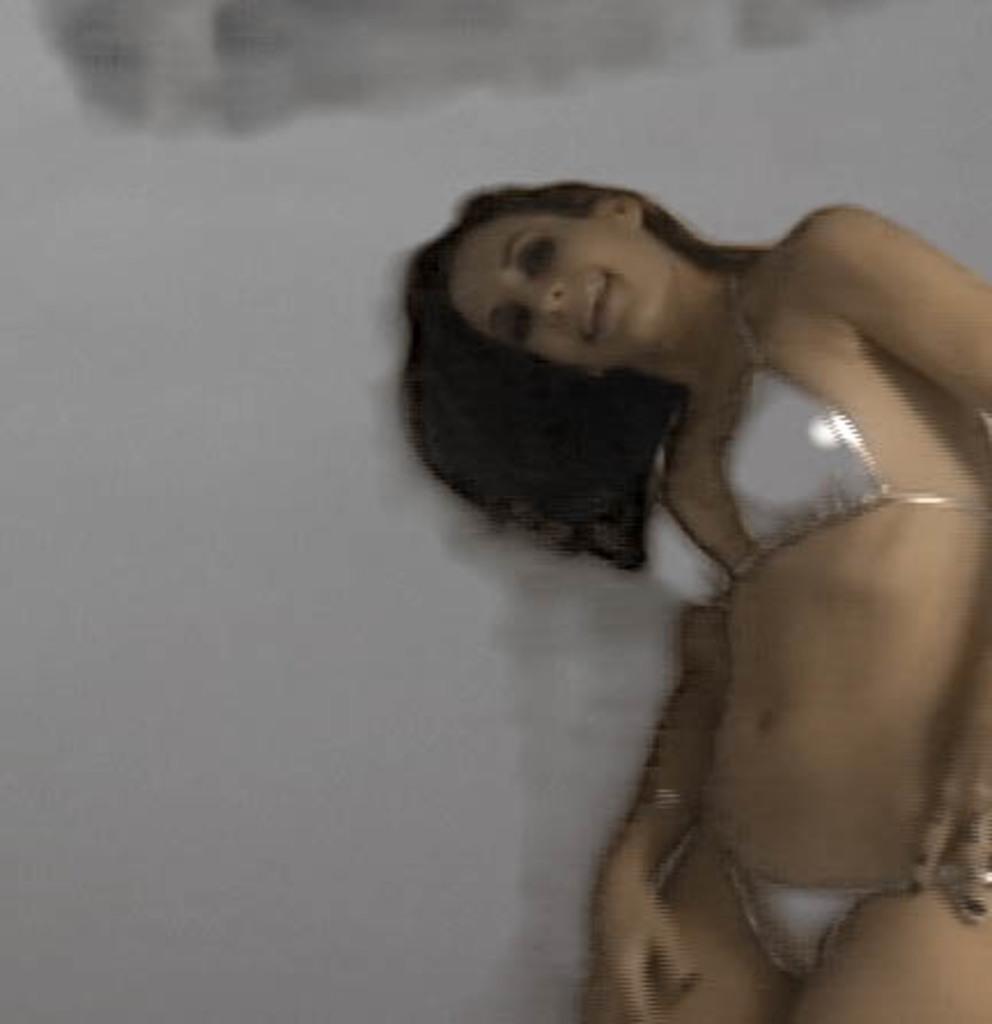How would you summarize this image in a sentence or two? In this image, we can see a person in front of the wall. 